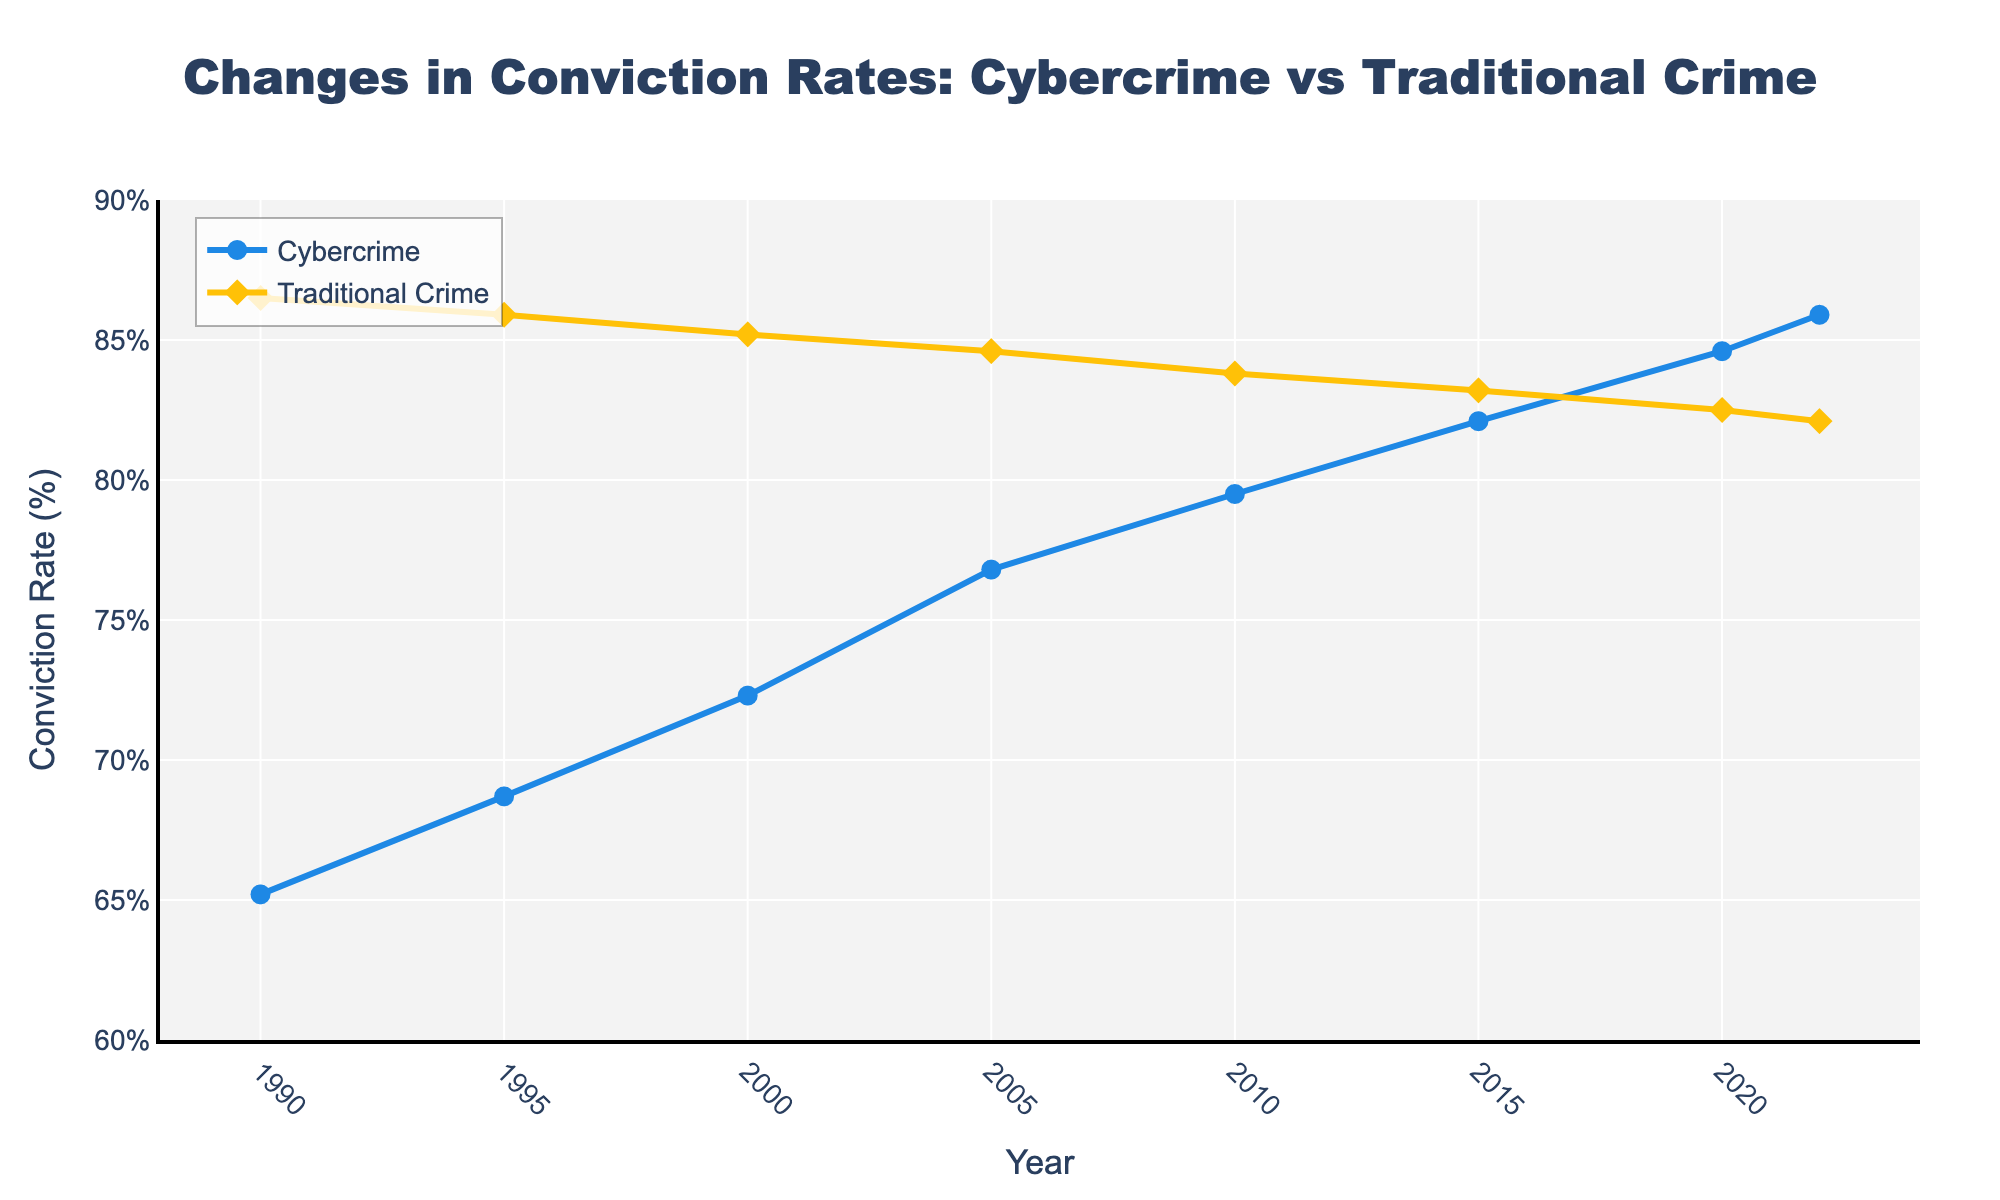What is the trend in the conviction rate for cybercrimes from 1990 to 2022? The chart shows a consistent increase in the conviction rate for cybercrimes, starting at 65.2% in 1990 and rising to 85.9% in 2022.
Answer: A consistent increase How does the conviction rate for traditional crimes in 2000 compare to that in 2022? The conviction rate for traditional crimes in 2000 was 85.2%, while in 2022, it was 82.1%. To compare, 85.2% is greater than 82.1%.
Answer: Lower in 2022 Between which years did the cybercrime conviction rate see the greatest increase? To find this, we calculate the increase between each interval and compare them. The increases are: 3.5% (1990-1995), 3.6% (1995-2000), 4.5% (2000-2005), 2.7% (2005-2010), 2.6% (2010-2015), 2.5% (2015-2020), 1.3% (2020-2022). The greatest increase was between 2000 and 2005.
Answer: 2000-2005 What was the difference between the conviction rates for cybercrimes and traditional crimes in 1990? The cybercrime conviction rate in 1990 was 65.2%, and the traditional crime conviction rate was 86.5%. The difference is 86.5% - 65.2% = 21.3%.
Answer: 21.3% Is there any point where the conviction rates for cybercrimes and traditional crimes are equal? Reviewing the graph, there is no point where the lines representing cybercrime and traditional crime conviction rates intersect. Thus, their rates are never equal.
Answer: No In which year did cybercrime conviction rates surpass 80%? Referring to the chart, the cybercrime conviction rate surpassed 80% in 2010 when it reached 82.1%.
Answer: 2010 By how much did the traditional crime conviction rate decrease from the year 2000 to 2022? The traditional crime conviction rate was 85.2% in 2000 and 82.1% in 2022. The decrease is 85.2% - 82.1% = 3.1%.
Answer: 3.1% Comparing 2015, which conviction rate was higher: cybercrime or traditional crime? In 2015, the cybercrime conviction rate was 82.1%, while the traditional crime conviction rate was 83.2%. The traditional crime conviction rate was higher.
Answer: Traditional crime What's the average cybercrime conviction rate from 1990 to 2005? The data points for cybercrime conviction rates from 1990 to 2005 are 65.2%, 68.7%, 72.3%, and 76.8%. The average is (65.2 + 68.7 + 72.3 + 76.8) / 4 = 70.75%.
Answer: 70.75% Which year shows the smallest decline in the conviction rate for traditional crimes compared to the previous year? Comparing each pair of consecutive years for the smallest decline: (1990-1995: 0.6%, 1995-2000: 0.7%, 2000-2005: 0.6%, 2005-2010: 0.8%, 2010-2015: 0.6%, 2015-2020: 0.7%, 2020-2022: 0.4%), the smallest decline is between 2020 and 2022.
Answer: 2020-2022 